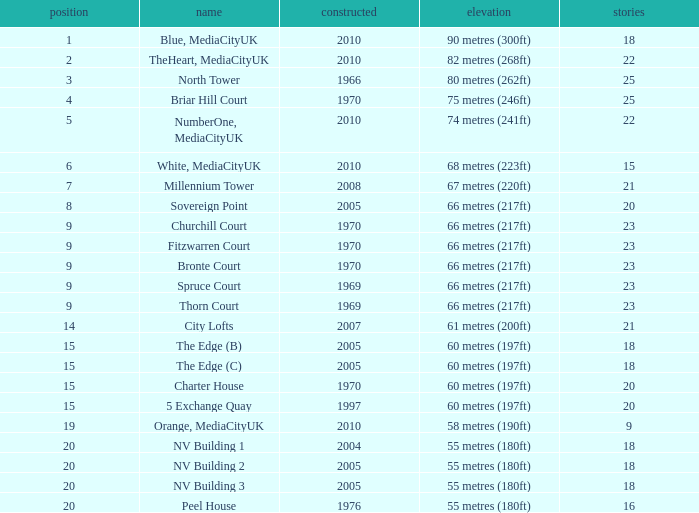Could you parse the entire table as a dict? {'header': ['position', 'name', 'constructed', 'elevation', 'stories'], 'rows': [['1', 'Blue, MediaCityUK', '2010', '90 metres (300ft)', '18'], ['2', 'TheHeart, MediaCityUK', '2010', '82 metres (268ft)', '22'], ['3', 'North Tower', '1966', '80 metres (262ft)', '25'], ['4', 'Briar Hill Court', '1970', '75 metres (246ft)', '25'], ['5', 'NumberOne, MediaCityUK', '2010', '74 metres (241ft)', '22'], ['6', 'White, MediaCityUK', '2010', '68 metres (223ft)', '15'], ['7', 'Millennium Tower', '2008', '67 metres (220ft)', '21'], ['8', 'Sovereign Point', '2005', '66 metres (217ft)', '20'], ['9', 'Churchill Court', '1970', '66 metres (217ft)', '23'], ['9', 'Fitzwarren Court', '1970', '66 metres (217ft)', '23'], ['9', 'Bronte Court', '1970', '66 metres (217ft)', '23'], ['9', 'Spruce Court', '1969', '66 metres (217ft)', '23'], ['9', 'Thorn Court', '1969', '66 metres (217ft)', '23'], ['14', 'City Lofts', '2007', '61 metres (200ft)', '21'], ['15', 'The Edge (B)', '2005', '60 metres (197ft)', '18'], ['15', 'The Edge (C)', '2005', '60 metres (197ft)', '18'], ['15', 'Charter House', '1970', '60 metres (197ft)', '20'], ['15', '5 Exchange Quay', '1997', '60 metres (197ft)', '20'], ['19', 'Orange, MediaCityUK', '2010', '58 metres (190ft)', '9'], ['20', 'NV Building 1', '2004', '55 metres (180ft)', '18'], ['20', 'NV Building 2', '2005', '55 metres (180ft)', '18'], ['20', 'NV Building 3', '2005', '55 metres (180ft)', '18'], ['20', 'Peel House', '1976', '55 metres (180ft)', '16']]} What is the lowest Built, when Floors is greater than 23, and when Rank is 3? 1966.0. 